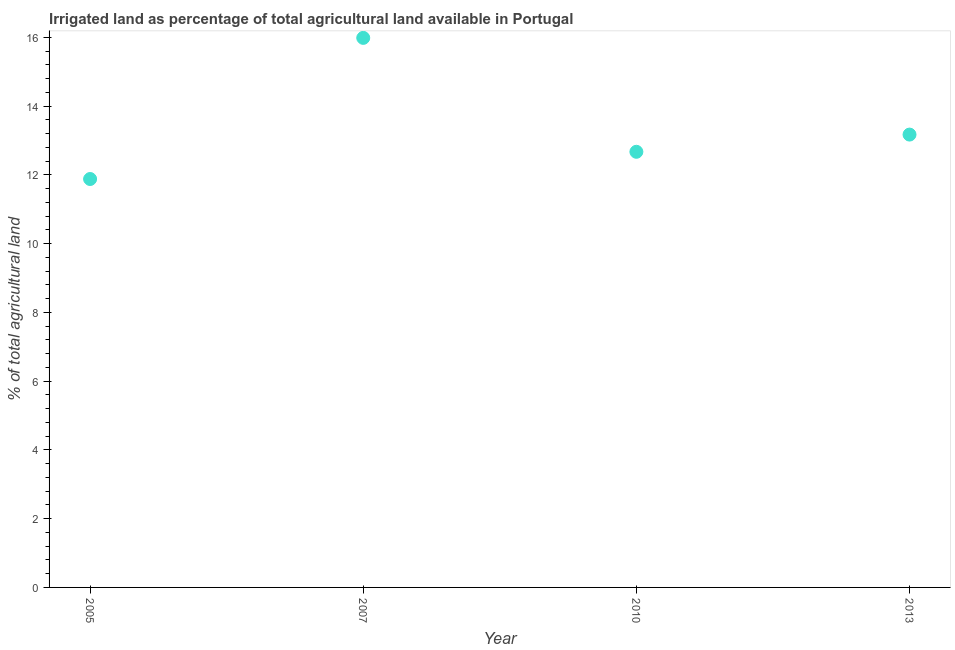What is the percentage of agricultural irrigated land in 2005?
Provide a succinct answer. 11.88. Across all years, what is the maximum percentage of agricultural irrigated land?
Give a very brief answer. 15.99. Across all years, what is the minimum percentage of agricultural irrigated land?
Ensure brevity in your answer.  11.88. In which year was the percentage of agricultural irrigated land maximum?
Provide a succinct answer. 2007. What is the sum of the percentage of agricultural irrigated land?
Keep it short and to the point. 53.72. What is the difference between the percentage of agricultural irrigated land in 2005 and 2007?
Make the answer very short. -4.11. What is the average percentage of agricultural irrigated land per year?
Your response must be concise. 13.43. What is the median percentage of agricultural irrigated land?
Make the answer very short. 12.92. In how many years, is the percentage of agricultural irrigated land greater than 0.4 %?
Your answer should be very brief. 4. What is the ratio of the percentage of agricultural irrigated land in 2005 to that in 2010?
Make the answer very short. 0.94. Is the difference between the percentage of agricultural irrigated land in 2005 and 2007 greater than the difference between any two years?
Provide a short and direct response. Yes. What is the difference between the highest and the second highest percentage of agricultural irrigated land?
Offer a terse response. 2.81. Is the sum of the percentage of agricultural irrigated land in 2005 and 2013 greater than the maximum percentage of agricultural irrigated land across all years?
Provide a short and direct response. Yes. What is the difference between the highest and the lowest percentage of agricultural irrigated land?
Keep it short and to the point. 4.11. In how many years, is the percentage of agricultural irrigated land greater than the average percentage of agricultural irrigated land taken over all years?
Provide a succinct answer. 1. Does the percentage of agricultural irrigated land monotonically increase over the years?
Provide a succinct answer. No. Are the values on the major ticks of Y-axis written in scientific E-notation?
Your answer should be compact. No. What is the title of the graph?
Ensure brevity in your answer.  Irrigated land as percentage of total agricultural land available in Portugal. What is the label or title of the Y-axis?
Provide a short and direct response. % of total agricultural land. What is the % of total agricultural land in 2005?
Your answer should be very brief. 11.88. What is the % of total agricultural land in 2007?
Give a very brief answer. 15.99. What is the % of total agricultural land in 2010?
Offer a terse response. 12.67. What is the % of total agricultural land in 2013?
Ensure brevity in your answer.  13.17. What is the difference between the % of total agricultural land in 2005 and 2007?
Offer a terse response. -4.11. What is the difference between the % of total agricultural land in 2005 and 2010?
Offer a terse response. -0.79. What is the difference between the % of total agricultural land in 2005 and 2013?
Offer a very short reply. -1.29. What is the difference between the % of total agricultural land in 2007 and 2010?
Make the answer very short. 3.31. What is the difference between the % of total agricultural land in 2007 and 2013?
Your answer should be very brief. 2.81. What is the difference between the % of total agricultural land in 2010 and 2013?
Keep it short and to the point. -0.5. What is the ratio of the % of total agricultural land in 2005 to that in 2007?
Offer a very short reply. 0.74. What is the ratio of the % of total agricultural land in 2005 to that in 2010?
Keep it short and to the point. 0.94. What is the ratio of the % of total agricultural land in 2005 to that in 2013?
Provide a short and direct response. 0.9. What is the ratio of the % of total agricultural land in 2007 to that in 2010?
Give a very brief answer. 1.26. What is the ratio of the % of total agricultural land in 2007 to that in 2013?
Keep it short and to the point. 1.21. 